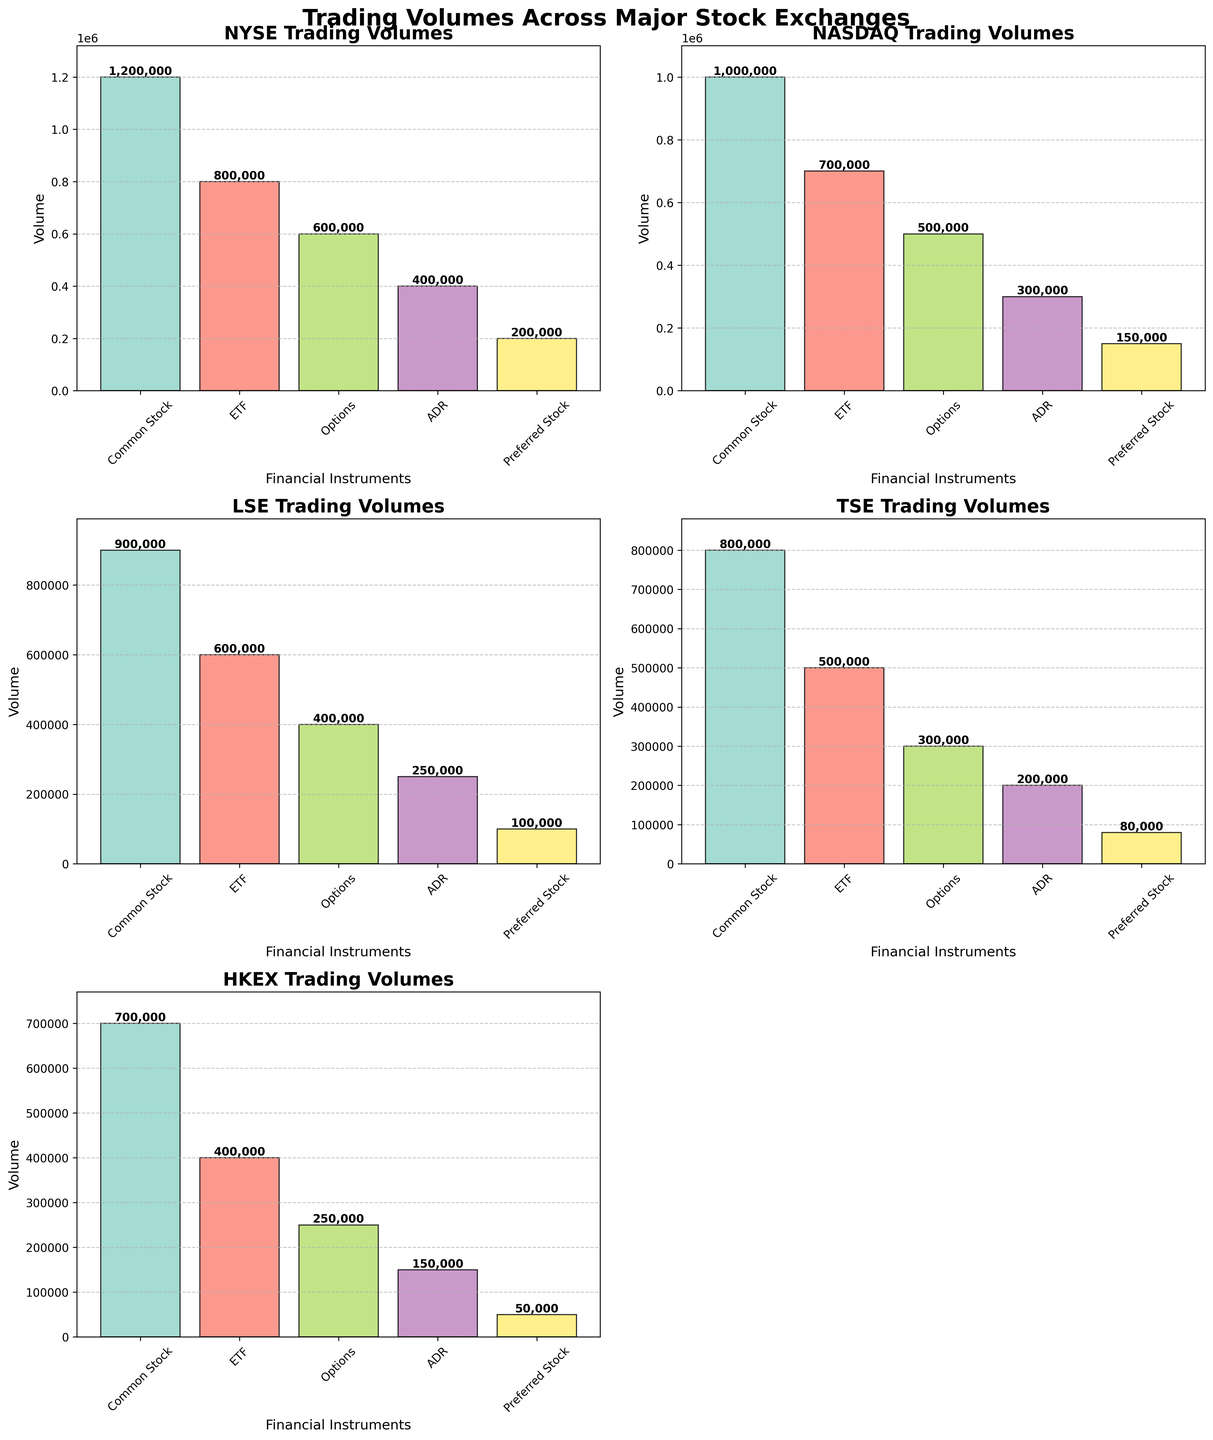What is the title of the figure? The title is usually located at the top of the figure and should be the largest text in the plot.
Answer: Trading Volumes Across Major Stock Exchanges Which exchange has the highest trading volume for Common Stock? Check the heights of the bars corresponding to Common Stock in each subplot and identify the tallest one.
Answer: NYSE Compare the trading volumes of ETFs between the NYSE and HKEX. Which one is higher? Locate the bars for ETFs in the NYSE and HKEX subplots. Compare their heights to determine which is higher.
Answer: NYSE What is the total volume traded for Options across all exchanges? Add up the volumes for Options from all subplots: 600,000 (NYSE) + 500,000 (NASDAQ) + 400,000 (LSE) + 300,000 (TSE) + 250,000 (HKEX).
Answer: 2,050,000 Which financial instrument has the lowest trading volume in the LSE? Identify the smallest bar height in the LSE subplot.
Answer: Preferred Stock What is the average trading volume of ADRs across all exchanges? Add the volumes of ADRs from all subplots and divide by the number of exchanges: (400,000 + 300,000 + 250,000 + 200,000 + 150,000)/5.
Answer: 260,000 By how much does the trading volume of Common Stock on the NYSE exceed that on the HKEX? Subtract the trading volume of Common Stock on HKEX from that on the NYSE: 1,200,000 - 700,000.
Answer: 500,000 Which exchange shows the smallest variation in trading volumes across different financial instruments? Compare the range of trading volumes (max volume - min volume) for each subplot and identify the smallest range.
Answer: HKEX How do the trading volumes of Preferred Stock compare between the TSE and NASDAQ? Examine the heights of the Preferred Stock bars in the TSE and NASDAQ subplots and determine which is higher or if they are equal.
Answer: NASDAQ 